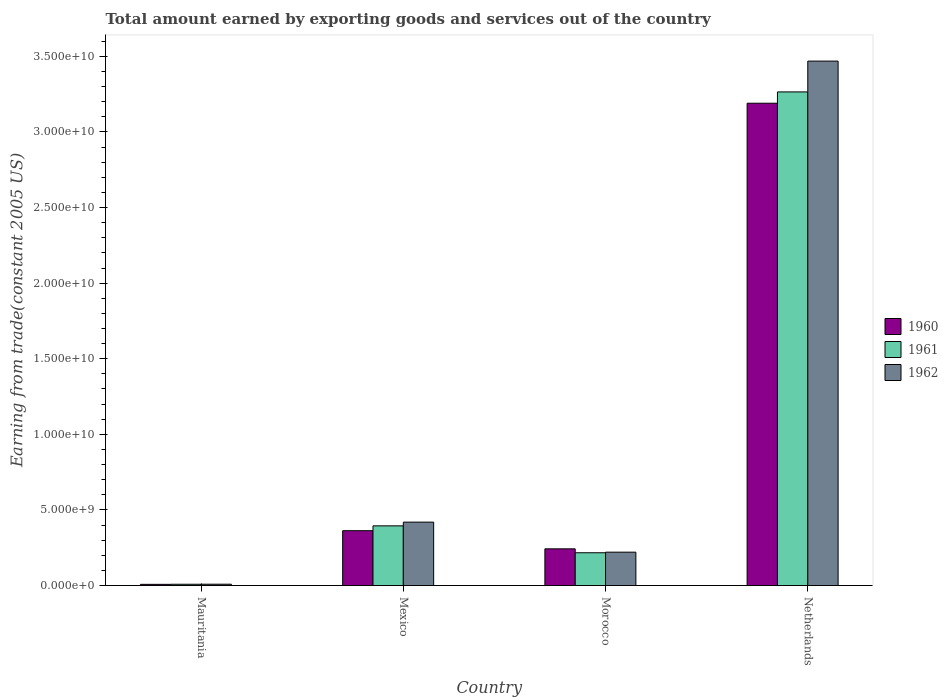How many groups of bars are there?
Give a very brief answer. 4. Are the number of bars per tick equal to the number of legend labels?
Your answer should be very brief. Yes. How many bars are there on the 2nd tick from the left?
Provide a succinct answer. 3. How many bars are there on the 1st tick from the right?
Your response must be concise. 3. What is the label of the 2nd group of bars from the left?
Your answer should be very brief. Mexico. What is the total amount earned by exporting goods and services in 1961 in Mexico?
Make the answer very short. 3.95e+09. Across all countries, what is the maximum total amount earned by exporting goods and services in 1960?
Your response must be concise. 3.19e+1. Across all countries, what is the minimum total amount earned by exporting goods and services in 1962?
Make the answer very short. 8.95e+07. In which country was the total amount earned by exporting goods and services in 1961 maximum?
Your response must be concise. Netherlands. In which country was the total amount earned by exporting goods and services in 1962 minimum?
Keep it short and to the point. Mauritania. What is the total total amount earned by exporting goods and services in 1962 in the graph?
Your answer should be compact. 4.12e+1. What is the difference between the total amount earned by exporting goods and services in 1962 in Mauritania and that in Netherlands?
Give a very brief answer. -3.46e+1. What is the difference between the total amount earned by exporting goods and services in 1962 in Morocco and the total amount earned by exporting goods and services in 1960 in Mexico?
Provide a succinct answer. -1.42e+09. What is the average total amount earned by exporting goods and services in 1960 per country?
Make the answer very short. 9.51e+09. What is the difference between the total amount earned by exporting goods and services of/in 1961 and total amount earned by exporting goods and services of/in 1960 in Netherlands?
Ensure brevity in your answer.  7.48e+08. What is the ratio of the total amount earned by exporting goods and services in 1962 in Mauritania to that in Netherlands?
Offer a very short reply. 0. Is the total amount earned by exporting goods and services in 1962 in Mauritania less than that in Mexico?
Provide a succinct answer. Yes. What is the difference between the highest and the second highest total amount earned by exporting goods and services in 1960?
Keep it short and to the point. 2.83e+1. What is the difference between the highest and the lowest total amount earned by exporting goods and services in 1962?
Provide a short and direct response. 3.46e+1. In how many countries, is the total amount earned by exporting goods and services in 1962 greater than the average total amount earned by exporting goods and services in 1962 taken over all countries?
Give a very brief answer. 1. Is the sum of the total amount earned by exporting goods and services in 1960 in Mauritania and Netherlands greater than the maximum total amount earned by exporting goods and services in 1962 across all countries?
Keep it short and to the point. No. How many bars are there?
Offer a very short reply. 12. Are all the bars in the graph horizontal?
Give a very brief answer. No. What is the difference between two consecutive major ticks on the Y-axis?
Make the answer very short. 5.00e+09. Does the graph contain any zero values?
Offer a very short reply. No. Where does the legend appear in the graph?
Ensure brevity in your answer.  Center right. How many legend labels are there?
Provide a succinct answer. 3. How are the legend labels stacked?
Ensure brevity in your answer.  Vertical. What is the title of the graph?
Offer a terse response. Total amount earned by exporting goods and services out of the country. What is the label or title of the X-axis?
Your answer should be compact. Country. What is the label or title of the Y-axis?
Your answer should be compact. Earning from trade(constant 2005 US). What is the Earning from trade(constant 2005 US) of 1960 in Mauritania?
Offer a very short reply. 7.97e+07. What is the Earning from trade(constant 2005 US) of 1961 in Mauritania?
Your answer should be very brief. 8.64e+07. What is the Earning from trade(constant 2005 US) in 1962 in Mauritania?
Ensure brevity in your answer.  8.95e+07. What is the Earning from trade(constant 2005 US) of 1960 in Mexico?
Provide a short and direct response. 3.63e+09. What is the Earning from trade(constant 2005 US) in 1961 in Mexico?
Give a very brief answer. 3.95e+09. What is the Earning from trade(constant 2005 US) of 1962 in Mexico?
Your response must be concise. 4.19e+09. What is the Earning from trade(constant 2005 US) of 1960 in Morocco?
Offer a terse response. 2.43e+09. What is the Earning from trade(constant 2005 US) of 1961 in Morocco?
Offer a very short reply. 2.17e+09. What is the Earning from trade(constant 2005 US) in 1962 in Morocco?
Make the answer very short. 2.21e+09. What is the Earning from trade(constant 2005 US) in 1960 in Netherlands?
Provide a succinct answer. 3.19e+1. What is the Earning from trade(constant 2005 US) in 1961 in Netherlands?
Make the answer very short. 3.26e+1. What is the Earning from trade(constant 2005 US) of 1962 in Netherlands?
Your response must be concise. 3.47e+1. Across all countries, what is the maximum Earning from trade(constant 2005 US) in 1960?
Ensure brevity in your answer.  3.19e+1. Across all countries, what is the maximum Earning from trade(constant 2005 US) of 1961?
Offer a terse response. 3.26e+1. Across all countries, what is the maximum Earning from trade(constant 2005 US) in 1962?
Keep it short and to the point. 3.47e+1. Across all countries, what is the minimum Earning from trade(constant 2005 US) of 1960?
Ensure brevity in your answer.  7.97e+07. Across all countries, what is the minimum Earning from trade(constant 2005 US) in 1961?
Keep it short and to the point. 8.64e+07. Across all countries, what is the minimum Earning from trade(constant 2005 US) of 1962?
Ensure brevity in your answer.  8.95e+07. What is the total Earning from trade(constant 2005 US) in 1960 in the graph?
Your response must be concise. 3.80e+1. What is the total Earning from trade(constant 2005 US) in 1961 in the graph?
Your answer should be compact. 3.89e+1. What is the total Earning from trade(constant 2005 US) of 1962 in the graph?
Provide a short and direct response. 4.12e+1. What is the difference between the Earning from trade(constant 2005 US) in 1960 in Mauritania and that in Mexico?
Your answer should be very brief. -3.55e+09. What is the difference between the Earning from trade(constant 2005 US) of 1961 in Mauritania and that in Mexico?
Ensure brevity in your answer.  -3.86e+09. What is the difference between the Earning from trade(constant 2005 US) of 1962 in Mauritania and that in Mexico?
Your answer should be very brief. -4.10e+09. What is the difference between the Earning from trade(constant 2005 US) in 1960 in Mauritania and that in Morocco?
Give a very brief answer. -2.35e+09. What is the difference between the Earning from trade(constant 2005 US) of 1961 in Mauritania and that in Morocco?
Your response must be concise. -2.08e+09. What is the difference between the Earning from trade(constant 2005 US) of 1962 in Mauritania and that in Morocco?
Ensure brevity in your answer.  -2.12e+09. What is the difference between the Earning from trade(constant 2005 US) in 1960 in Mauritania and that in Netherlands?
Keep it short and to the point. -3.18e+1. What is the difference between the Earning from trade(constant 2005 US) of 1961 in Mauritania and that in Netherlands?
Your answer should be compact. -3.26e+1. What is the difference between the Earning from trade(constant 2005 US) of 1962 in Mauritania and that in Netherlands?
Give a very brief answer. -3.46e+1. What is the difference between the Earning from trade(constant 2005 US) of 1960 in Mexico and that in Morocco?
Offer a very short reply. 1.20e+09. What is the difference between the Earning from trade(constant 2005 US) in 1961 in Mexico and that in Morocco?
Offer a very short reply. 1.78e+09. What is the difference between the Earning from trade(constant 2005 US) in 1962 in Mexico and that in Morocco?
Your answer should be compact. 1.99e+09. What is the difference between the Earning from trade(constant 2005 US) of 1960 in Mexico and that in Netherlands?
Offer a very short reply. -2.83e+1. What is the difference between the Earning from trade(constant 2005 US) of 1961 in Mexico and that in Netherlands?
Your answer should be very brief. -2.87e+1. What is the difference between the Earning from trade(constant 2005 US) of 1962 in Mexico and that in Netherlands?
Your answer should be compact. -3.05e+1. What is the difference between the Earning from trade(constant 2005 US) of 1960 in Morocco and that in Netherlands?
Your answer should be compact. -2.95e+1. What is the difference between the Earning from trade(constant 2005 US) in 1961 in Morocco and that in Netherlands?
Your response must be concise. -3.05e+1. What is the difference between the Earning from trade(constant 2005 US) of 1962 in Morocco and that in Netherlands?
Your response must be concise. -3.25e+1. What is the difference between the Earning from trade(constant 2005 US) of 1960 in Mauritania and the Earning from trade(constant 2005 US) of 1961 in Mexico?
Keep it short and to the point. -3.87e+09. What is the difference between the Earning from trade(constant 2005 US) in 1960 in Mauritania and the Earning from trade(constant 2005 US) in 1962 in Mexico?
Offer a very short reply. -4.11e+09. What is the difference between the Earning from trade(constant 2005 US) of 1961 in Mauritania and the Earning from trade(constant 2005 US) of 1962 in Mexico?
Ensure brevity in your answer.  -4.11e+09. What is the difference between the Earning from trade(constant 2005 US) of 1960 in Mauritania and the Earning from trade(constant 2005 US) of 1961 in Morocco?
Make the answer very short. -2.09e+09. What is the difference between the Earning from trade(constant 2005 US) of 1960 in Mauritania and the Earning from trade(constant 2005 US) of 1962 in Morocco?
Give a very brief answer. -2.13e+09. What is the difference between the Earning from trade(constant 2005 US) in 1961 in Mauritania and the Earning from trade(constant 2005 US) in 1962 in Morocco?
Your answer should be compact. -2.12e+09. What is the difference between the Earning from trade(constant 2005 US) of 1960 in Mauritania and the Earning from trade(constant 2005 US) of 1961 in Netherlands?
Keep it short and to the point. -3.26e+1. What is the difference between the Earning from trade(constant 2005 US) of 1960 in Mauritania and the Earning from trade(constant 2005 US) of 1962 in Netherlands?
Offer a very short reply. -3.46e+1. What is the difference between the Earning from trade(constant 2005 US) of 1961 in Mauritania and the Earning from trade(constant 2005 US) of 1962 in Netherlands?
Offer a very short reply. -3.46e+1. What is the difference between the Earning from trade(constant 2005 US) of 1960 in Mexico and the Earning from trade(constant 2005 US) of 1961 in Morocco?
Your answer should be very brief. 1.46e+09. What is the difference between the Earning from trade(constant 2005 US) of 1960 in Mexico and the Earning from trade(constant 2005 US) of 1962 in Morocco?
Offer a very short reply. 1.42e+09. What is the difference between the Earning from trade(constant 2005 US) of 1961 in Mexico and the Earning from trade(constant 2005 US) of 1962 in Morocco?
Your answer should be very brief. 1.74e+09. What is the difference between the Earning from trade(constant 2005 US) of 1960 in Mexico and the Earning from trade(constant 2005 US) of 1961 in Netherlands?
Provide a short and direct response. -2.90e+1. What is the difference between the Earning from trade(constant 2005 US) of 1960 in Mexico and the Earning from trade(constant 2005 US) of 1962 in Netherlands?
Your response must be concise. -3.11e+1. What is the difference between the Earning from trade(constant 2005 US) in 1961 in Mexico and the Earning from trade(constant 2005 US) in 1962 in Netherlands?
Provide a succinct answer. -3.07e+1. What is the difference between the Earning from trade(constant 2005 US) of 1960 in Morocco and the Earning from trade(constant 2005 US) of 1961 in Netherlands?
Your response must be concise. -3.02e+1. What is the difference between the Earning from trade(constant 2005 US) of 1960 in Morocco and the Earning from trade(constant 2005 US) of 1962 in Netherlands?
Your answer should be very brief. -3.23e+1. What is the difference between the Earning from trade(constant 2005 US) in 1961 in Morocco and the Earning from trade(constant 2005 US) in 1962 in Netherlands?
Provide a succinct answer. -3.25e+1. What is the average Earning from trade(constant 2005 US) in 1960 per country?
Provide a succinct answer. 9.51e+09. What is the average Earning from trade(constant 2005 US) of 1961 per country?
Make the answer very short. 9.71e+09. What is the average Earning from trade(constant 2005 US) of 1962 per country?
Your answer should be very brief. 1.03e+1. What is the difference between the Earning from trade(constant 2005 US) of 1960 and Earning from trade(constant 2005 US) of 1961 in Mauritania?
Offer a very short reply. -6.74e+06. What is the difference between the Earning from trade(constant 2005 US) in 1960 and Earning from trade(constant 2005 US) in 1962 in Mauritania?
Provide a succinct answer. -9.81e+06. What is the difference between the Earning from trade(constant 2005 US) in 1961 and Earning from trade(constant 2005 US) in 1962 in Mauritania?
Provide a short and direct response. -3.07e+06. What is the difference between the Earning from trade(constant 2005 US) of 1960 and Earning from trade(constant 2005 US) of 1961 in Mexico?
Your answer should be very brief. -3.21e+08. What is the difference between the Earning from trade(constant 2005 US) in 1960 and Earning from trade(constant 2005 US) in 1962 in Mexico?
Your answer should be compact. -5.66e+08. What is the difference between the Earning from trade(constant 2005 US) in 1961 and Earning from trade(constant 2005 US) in 1962 in Mexico?
Make the answer very short. -2.45e+08. What is the difference between the Earning from trade(constant 2005 US) of 1960 and Earning from trade(constant 2005 US) of 1961 in Morocco?
Ensure brevity in your answer.  2.59e+08. What is the difference between the Earning from trade(constant 2005 US) in 1960 and Earning from trade(constant 2005 US) in 1962 in Morocco?
Provide a short and direct response. 2.19e+08. What is the difference between the Earning from trade(constant 2005 US) of 1961 and Earning from trade(constant 2005 US) of 1962 in Morocco?
Ensure brevity in your answer.  -3.93e+07. What is the difference between the Earning from trade(constant 2005 US) in 1960 and Earning from trade(constant 2005 US) in 1961 in Netherlands?
Keep it short and to the point. -7.48e+08. What is the difference between the Earning from trade(constant 2005 US) of 1960 and Earning from trade(constant 2005 US) of 1962 in Netherlands?
Provide a succinct answer. -2.79e+09. What is the difference between the Earning from trade(constant 2005 US) of 1961 and Earning from trade(constant 2005 US) of 1962 in Netherlands?
Give a very brief answer. -2.04e+09. What is the ratio of the Earning from trade(constant 2005 US) of 1960 in Mauritania to that in Mexico?
Provide a succinct answer. 0.02. What is the ratio of the Earning from trade(constant 2005 US) in 1961 in Mauritania to that in Mexico?
Provide a short and direct response. 0.02. What is the ratio of the Earning from trade(constant 2005 US) in 1962 in Mauritania to that in Mexico?
Offer a very short reply. 0.02. What is the ratio of the Earning from trade(constant 2005 US) in 1960 in Mauritania to that in Morocco?
Your answer should be very brief. 0.03. What is the ratio of the Earning from trade(constant 2005 US) in 1961 in Mauritania to that in Morocco?
Your answer should be very brief. 0.04. What is the ratio of the Earning from trade(constant 2005 US) of 1962 in Mauritania to that in Morocco?
Provide a short and direct response. 0.04. What is the ratio of the Earning from trade(constant 2005 US) of 1960 in Mauritania to that in Netherlands?
Ensure brevity in your answer.  0. What is the ratio of the Earning from trade(constant 2005 US) in 1961 in Mauritania to that in Netherlands?
Ensure brevity in your answer.  0. What is the ratio of the Earning from trade(constant 2005 US) of 1962 in Mauritania to that in Netherlands?
Provide a succinct answer. 0. What is the ratio of the Earning from trade(constant 2005 US) in 1960 in Mexico to that in Morocco?
Your response must be concise. 1.49. What is the ratio of the Earning from trade(constant 2005 US) in 1961 in Mexico to that in Morocco?
Give a very brief answer. 1.82. What is the ratio of the Earning from trade(constant 2005 US) of 1962 in Mexico to that in Morocco?
Make the answer very short. 1.9. What is the ratio of the Earning from trade(constant 2005 US) of 1960 in Mexico to that in Netherlands?
Your response must be concise. 0.11. What is the ratio of the Earning from trade(constant 2005 US) in 1961 in Mexico to that in Netherlands?
Your answer should be very brief. 0.12. What is the ratio of the Earning from trade(constant 2005 US) of 1962 in Mexico to that in Netherlands?
Provide a succinct answer. 0.12. What is the ratio of the Earning from trade(constant 2005 US) in 1960 in Morocco to that in Netherlands?
Give a very brief answer. 0.08. What is the ratio of the Earning from trade(constant 2005 US) in 1961 in Morocco to that in Netherlands?
Keep it short and to the point. 0.07. What is the ratio of the Earning from trade(constant 2005 US) in 1962 in Morocco to that in Netherlands?
Your response must be concise. 0.06. What is the difference between the highest and the second highest Earning from trade(constant 2005 US) in 1960?
Offer a terse response. 2.83e+1. What is the difference between the highest and the second highest Earning from trade(constant 2005 US) in 1961?
Offer a terse response. 2.87e+1. What is the difference between the highest and the second highest Earning from trade(constant 2005 US) of 1962?
Make the answer very short. 3.05e+1. What is the difference between the highest and the lowest Earning from trade(constant 2005 US) of 1960?
Offer a terse response. 3.18e+1. What is the difference between the highest and the lowest Earning from trade(constant 2005 US) in 1961?
Your response must be concise. 3.26e+1. What is the difference between the highest and the lowest Earning from trade(constant 2005 US) of 1962?
Offer a terse response. 3.46e+1. 